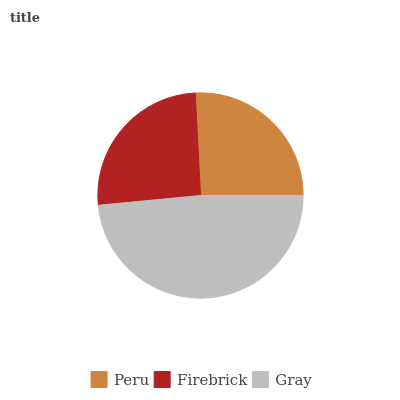Is Firebrick the minimum?
Answer yes or no. Yes. Is Gray the maximum?
Answer yes or no. Yes. Is Gray the minimum?
Answer yes or no. No. Is Firebrick the maximum?
Answer yes or no. No. Is Gray greater than Firebrick?
Answer yes or no. Yes. Is Firebrick less than Gray?
Answer yes or no. Yes. Is Firebrick greater than Gray?
Answer yes or no. No. Is Gray less than Firebrick?
Answer yes or no. No. Is Peru the high median?
Answer yes or no. Yes. Is Peru the low median?
Answer yes or no. Yes. Is Firebrick the high median?
Answer yes or no. No. Is Gray the low median?
Answer yes or no. No. 